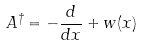<formula> <loc_0><loc_0><loc_500><loc_500>A ^ { \dagger } = - \frac { d } { d x } + w ( x )</formula> 